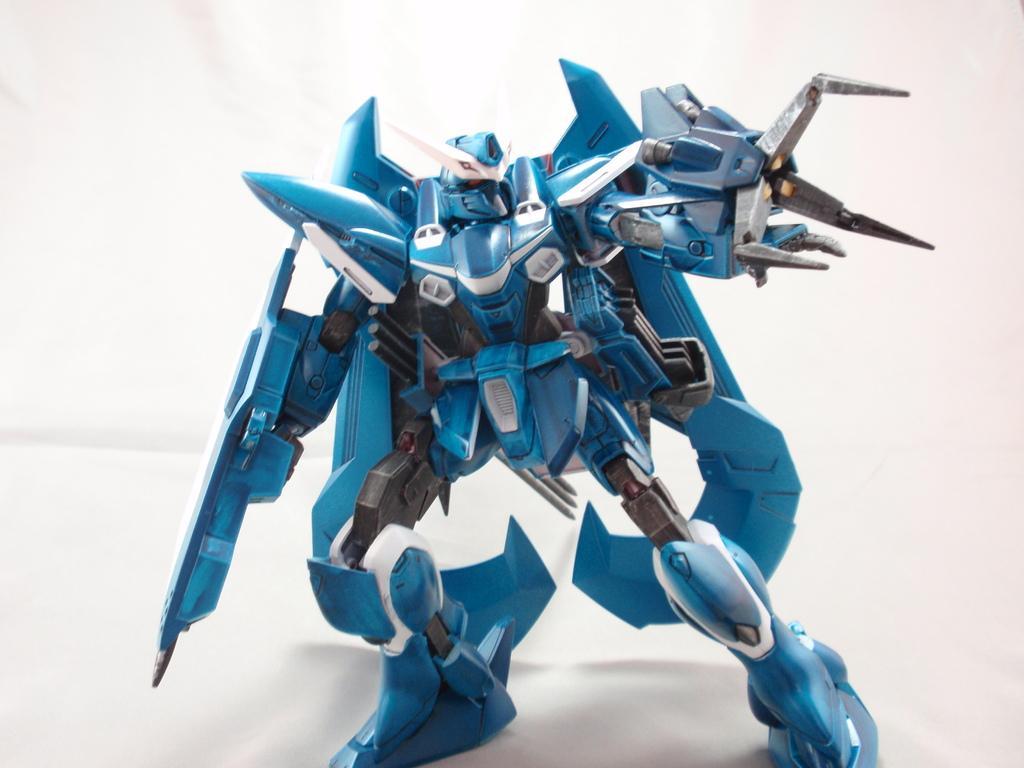Describe this image in one or two sentences. In the center of this picture we can see a toy robot standing and the background of the image is white in color. 